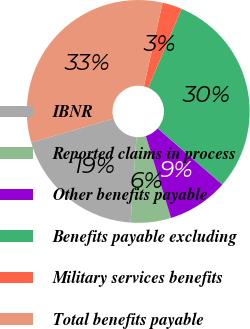<chart> <loc_0><loc_0><loc_500><loc_500><pie_chart><fcel>IBNR<fcel>Reported claims in process<fcel>Other benefits payable<fcel>Benefits payable excluding<fcel>Military services benefits<fcel>Total benefits payable<nl><fcel>19.41%<fcel>5.85%<fcel>8.85%<fcel>30.02%<fcel>2.85%<fcel>33.02%<nl></chart> 